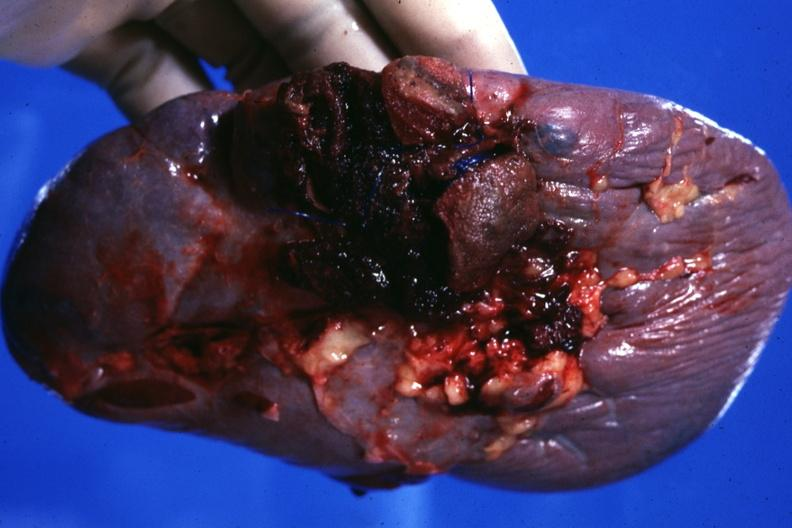s spleen present?
Answer the question using a single word or phrase. Yes 